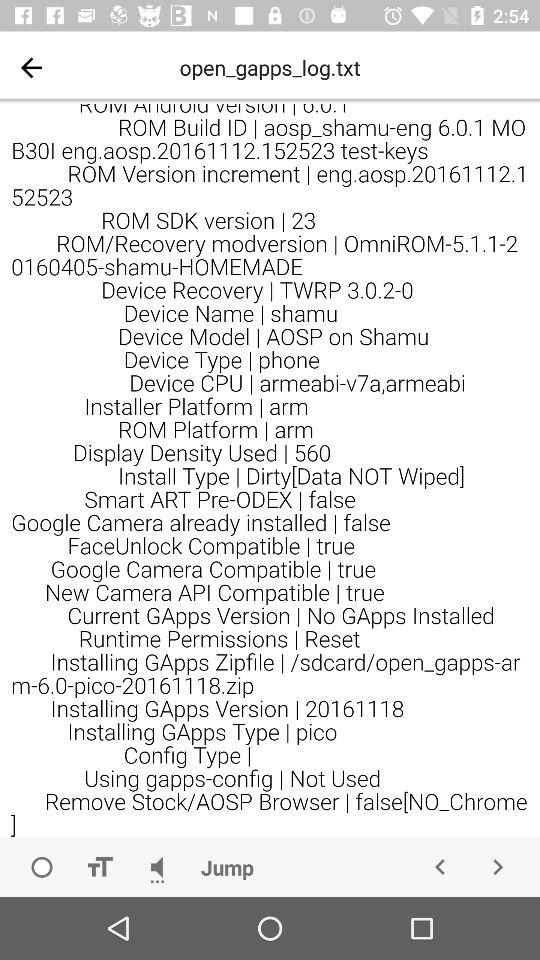What is the "ROM/Recovery modversion"? The "ROM/Recovery modversion" is "OmniROM-5.1.1-20160405-shamu-HOMEMADE". 